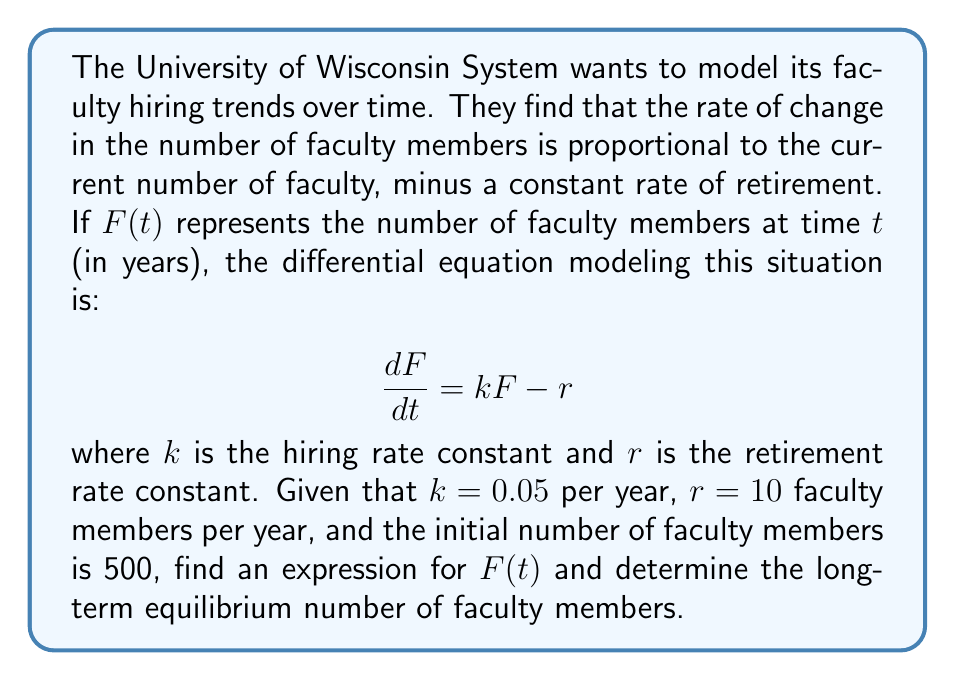Help me with this question. To solve this first-order linear differential equation:

1) Rearrange the equation:
   $$\frac{dF}{dt} + (-k)F = r$$

2) This is in the form $\frac{dy}{dx} + P(x)y = Q(x)$, where $P(x) = -k$ and $Q(x) = r$

3) The integrating factor is $e^{\int P(x)dx} = e^{-kt}$

4) Multiply both sides by the integrating factor:
   $$e^{-kt}\frac{dF}{dt} + e^{-kt}(-k)F = re^{-kt}$$

5) The left side is now the derivative of $e^{-kt}F$:
   $$\frac{d}{dt}(e^{-kt}F) = re^{-kt}$$

6) Integrate both sides:
   $$e^{-kt}F = -\frac{r}{k}e^{-kt} + C$$

7) Solve for $F$:
   $$F(t) = -\frac{r}{k} + Ce^{kt}$$

8) Use the initial condition $F(0) = 500$ to find $C$:
   $$500 = -\frac{r}{k} + C$$
   $$C = 500 + \frac{r}{k} = 500 + \frac{10}{0.05} = 700$$

9) The complete solution is:
   $$F(t) = -\frac{r}{k} + (500 + \frac{r}{k})e^{kt}$$
   $$F(t) = -200 + 700e^{0.05t}$$

10) To find the long-term equilibrium, take the limit as $t$ approaches infinity:
    $$\lim_{t \to \infty} F(t) = \lim_{t \to \infty} (-200 + 700e^{0.05t}) = \infty$$

However, this unbounded growth is unrealistic. In practice, the equilibrium occurs when $\frac{dF}{dt} = 0$:

$$0 = kF - r$$
$$F = \frac{r}{k} = \frac{10}{0.05} = 200$$

Therefore, the long-term equilibrium number of faculty members is 200.
Answer: The expression for $F(t)$ is $F(t) = -200 + 700e^{0.05t}$, and the long-term equilibrium number of faculty members is 200. 